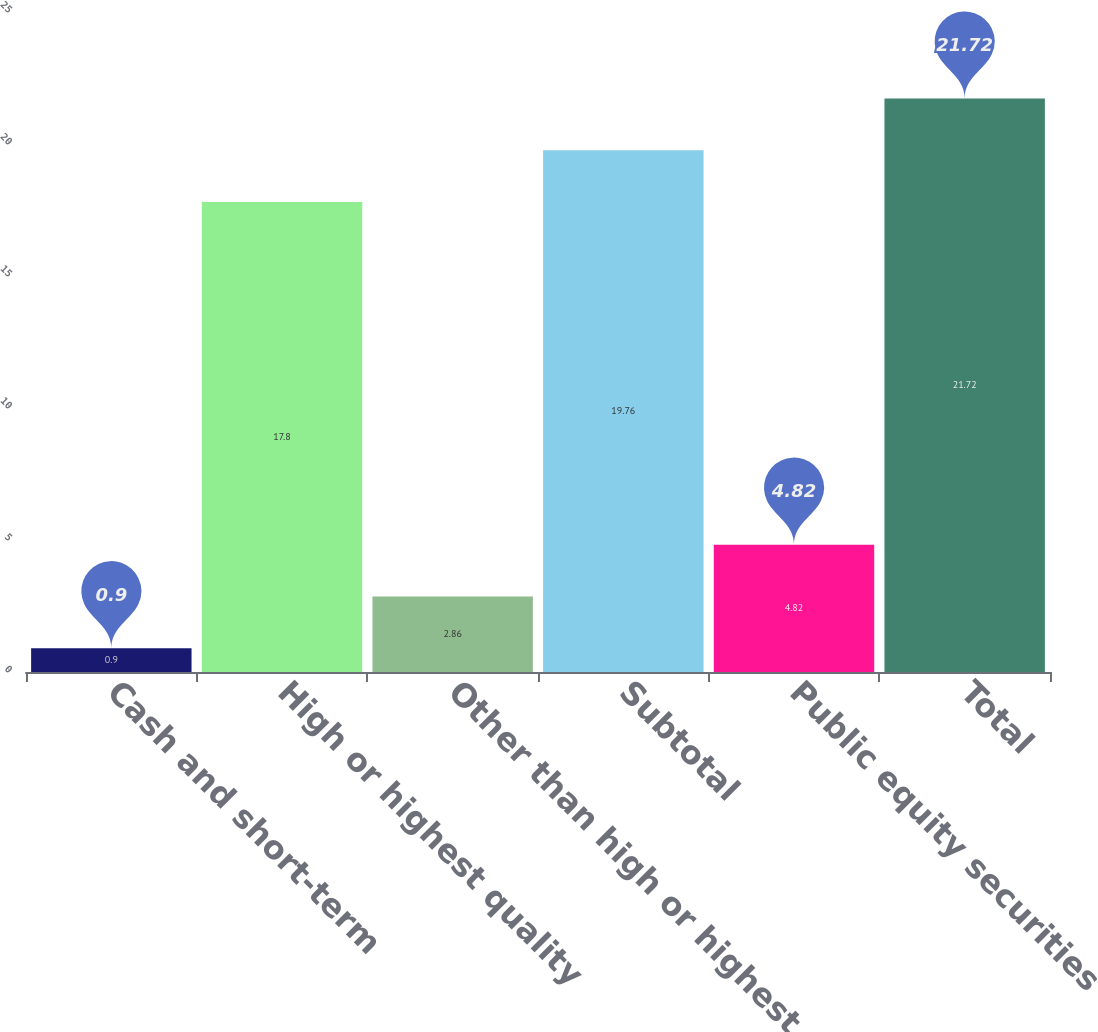<chart> <loc_0><loc_0><loc_500><loc_500><bar_chart><fcel>Cash and short-term<fcel>High or highest quality<fcel>Other than high or highest<fcel>Subtotal<fcel>Public equity securities<fcel>Total<nl><fcel>0.9<fcel>17.8<fcel>2.86<fcel>19.76<fcel>4.82<fcel>21.72<nl></chart> 